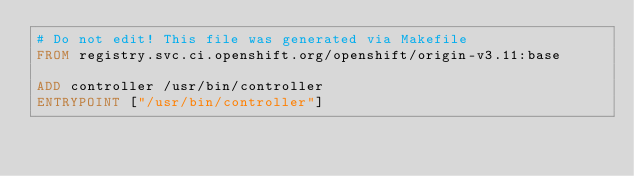Convert code to text. <code><loc_0><loc_0><loc_500><loc_500><_Dockerfile_># Do not edit! This file was generated via Makefile
FROM registry.svc.ci.openshift.org/openshift/origin-v3.11:base

ADD controller /usr/bin/controller
ENTRYPOINT ["/usr/bin/controller"]
</code> 